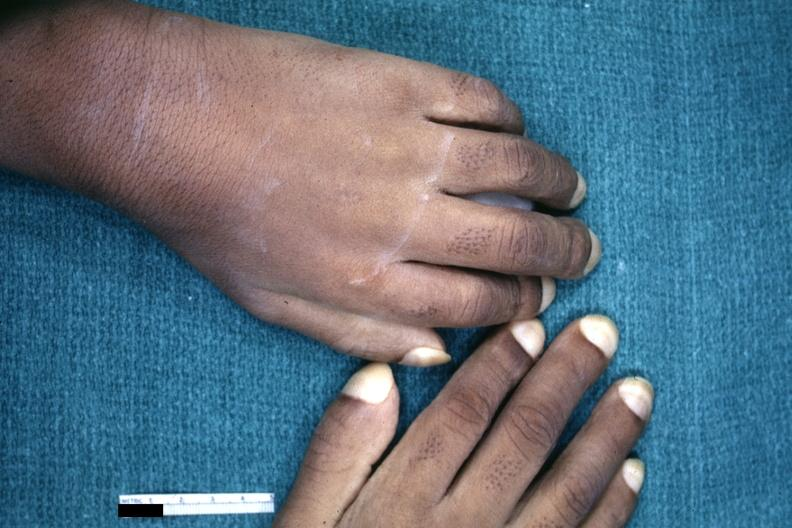what is present?
Answer the question using a single word or phrase. Pulmonary osteoarthropathy 